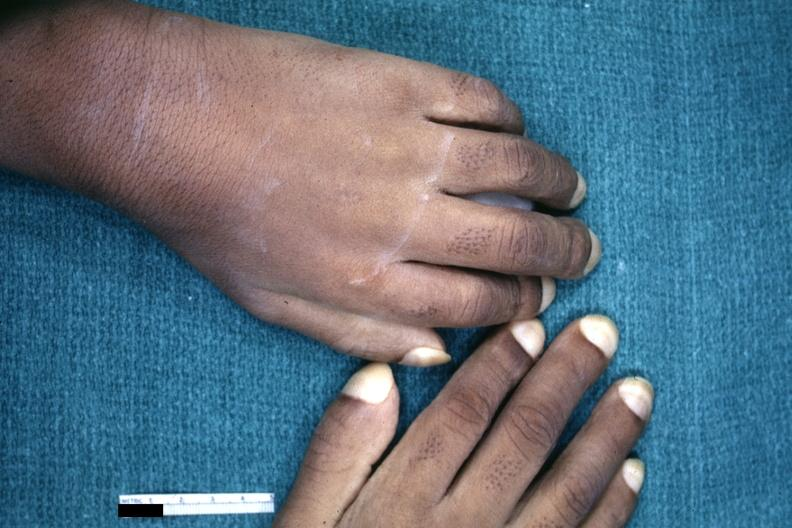what is present?
Answer the question using a single word or phrase. Pulmonary osteoarthropathy 